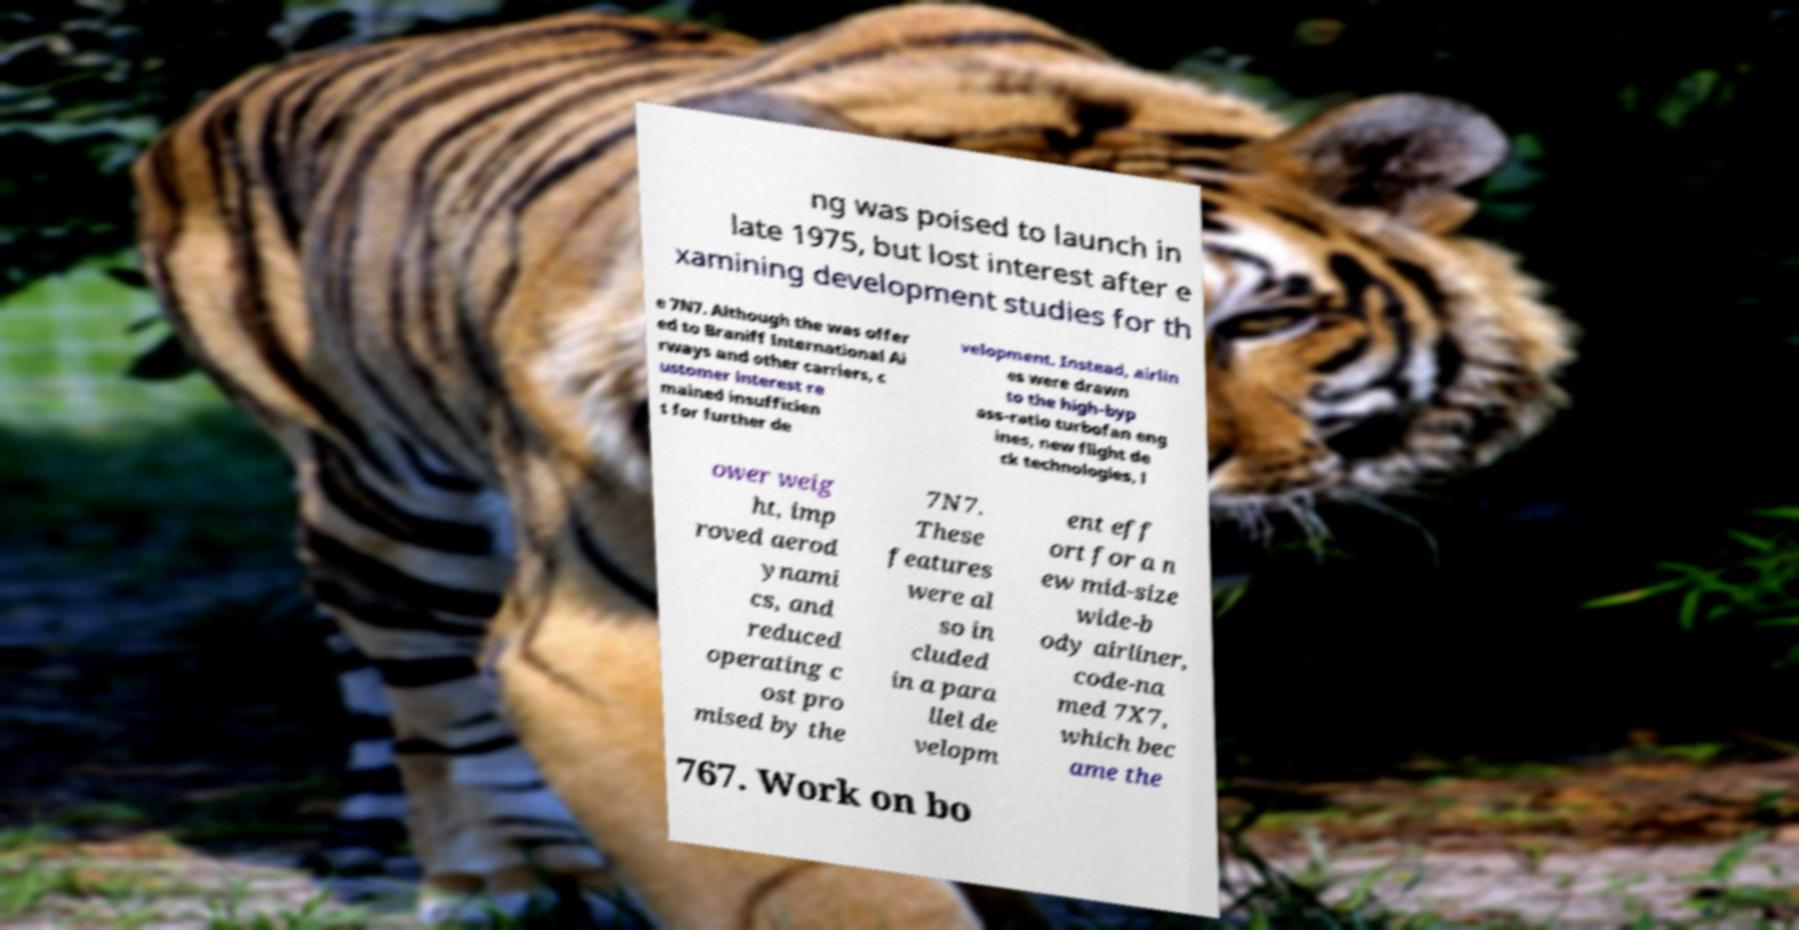Could you extract and type out the text from this image? ng was poised to launch in late 1975, but lost interest after e xamining development studies for th e 7N7. Although the was offer ed to Braniff International Ai rways and other carriers, c ustomer interest re mained insufficien t for further de velopment. Instead, airlin es were drawn to the high-byp ass-ratio turbofan eng ines, new flight de ck technologies, l ower weig ht, imp roved aerod ynami cs, and reduced operating c ost pro mised by the 7N7. These features were al so in cluded in a para llel de velopm ent eff ort for a n ew mid-size wide-b ody airliner, code-na med 7X7, which bec ame the 767. Work on bo 